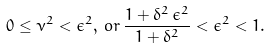<formula> <loc_0><loc_0><loc_500><loc_500>0 \leq \nu ^ { 2 } < \epsilon ^ { 2 } , \, o r \, \frac { 1 + \delta ^ { 2 } \, \epsilon ^ { 2 } } { 1 + \delta ^ { 2 } } < \epsilon ^ { 2 } < 1 .</formula> 